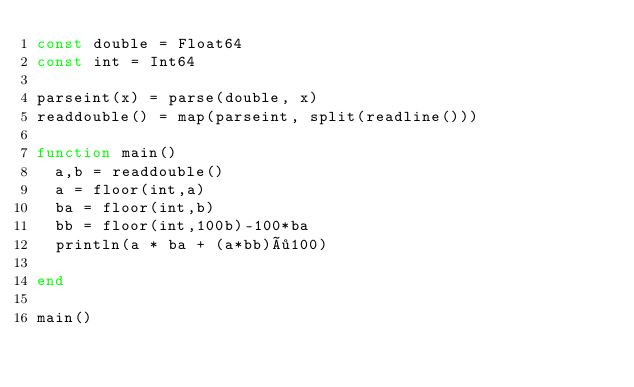<code> <loc_0><loc_0><loc_500><loc_500><_Julia_>const double = Float64
const int = Int64

parseint(x) = parse(double, x)
readdouble() = map(parseint, split(readline()))

function main()
  a,b = readdouble()
  a = floor(int,a)
  ba = floor(int,b)
  bb = floor(int,100b)-100*ba
  println(a * ba + (a*bb)÷100)
  
end

main()</code> 